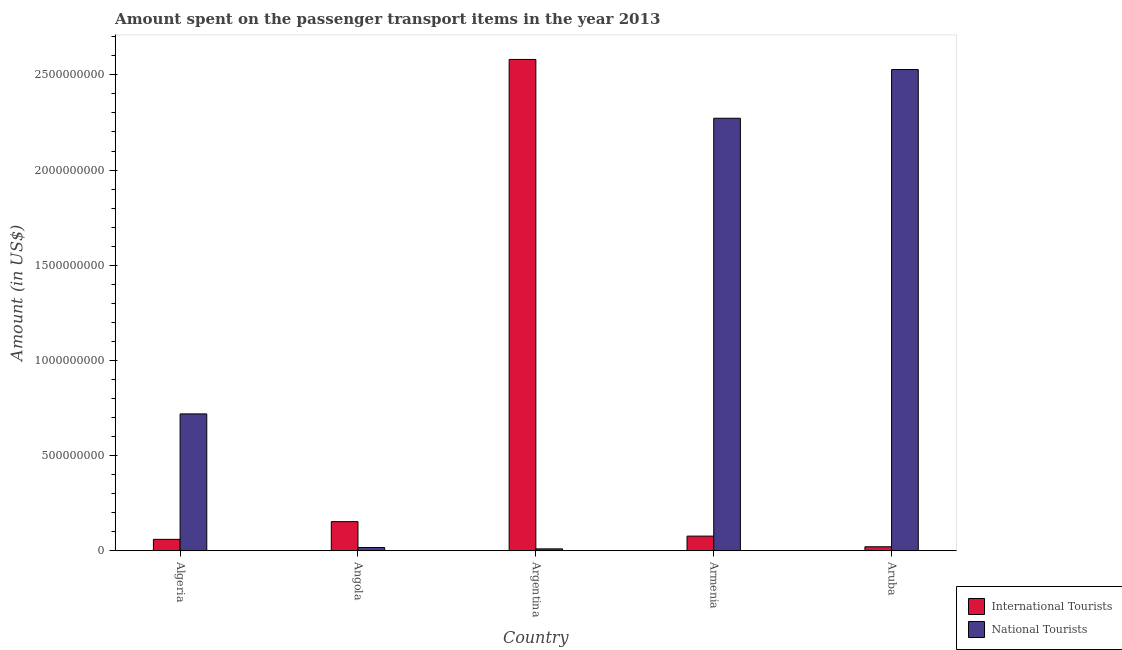How many different coloured bars are there?
Provide a short and direct response. 2. How many groups of bars are there?
Provide a short and direct response. 5. How many bars are there on the 4th tick from the right?
Your response must be concise. 2. What is the label of the 4th group of bars from the left?
Offer a terse response. Armenia. In how many cases, is the number of bars for a given country not equal to the number of legend labels?
Ensure brevity in your answer.  0. Across all countries, what is the maximum amount spent on transport items of international tourists?
Offer a very short reply. 2.58e+09. Across all countries, what is the minimum amount spent on transport items of international tourists?
Offer a terse response. 2.10e+07. In which country was the amount spent on transport items of international tourists maximum?
Provide a succinct answer. Argentina. In which country was the amount spent on transport items of international tourists minimum?
Provide a succinct answer. Aruba. What is the total amount spent on transport items of national tourists in the graph?
Keep it short and to the point. 5.55e+09. What is the difference between the amount spent on transport items of international tourists in Argentina and that in Aruba?
Provide a short and direct response. 2.56e+09. What is the difference between the amount spent on transport items of national tourists in Argentina and the amount spent on transport items of international tourists in Armenia?
Your answer should be very brief. -6.70e+07. What is the average amount spent on transport items of international tourists per country?
Offer a terse response. 5.78e+08. What is the difference between the amount spent on transport items of international tourists and amount spent on transport items of national tourists in Angola?
Offer a very short reply. 1.36e+08. What is the ratio of the amount spent on transport items of national tourists in Argentina to that in Aruba?
Your answer should be compact. 0. Is the difference between the amount spent on transport items of national tourists in Angola and Aruba greater than the difference between the amount spent on transport items of international tourists in Angola and Aruba?
Provide a succinct answer. No. What is the difference between the highest and the second highest amount spent on transport items of international tourists?
Provide a succinct answer. 2.43e+09. What is the difference between the highest and the lowest amount spent on transport items of national tourists?
Provide a short and direct response. 2.52e+09. What does the 2nd bar from the left in Argentina represents?
Keep it short and to the point. National Tourists. What does the 2nd bar from the right in Armenia represents?
Ensure brevity in your answer.  International Tourists. Are all the bars in the graph horizontal?
Ensure brevity in your answer.  No. Are the values on the major ticks of Y-axis written in scientific E-notation?
Offer a very short reply. No. What is the title of the graph?
Your answer should be very brief. Amount spent on the passenger transport items in the year 2013. Does "Female entrants" appear as one of the legend labels in the graph?
Your answer should be compact. No. What is the label or title of the Y-axis?
Offer a very short reply. Amount (in US$). What is the Amount (in US$) in International Tourists in Algeria?
Offer a terse response. 6.00e+07. What is the Amount (in US$) in National Tourists in Algeria?
Your response must be concise. 7.19e+08. What is the Amount (in US$) of International Tourists in Angola?
Your answer should be compact. 1.53e+08. What is the Amount (in US$) of National Tourists in Angola?
Keep it short and to the point. 1.70e+07. What is the Amount (in US$) in International Tourists in Argentina?
Provide a short and direct response. 2.58e+09. What is the Amount (in US$) in International Tourists in Armenia?
Give a very brief answer. 7.70e+07. What is the Amount (in US$) in National Tourists in Armenia?
Your answer should be compact. 2.27e+09. What is the Amount (in US$) in International Tourists in Aruba?
Make the answer very short. 2.10e+07. What is the Amount (in US$) of National Tourists in Aruba?
Your answer should be very brief. 2.53e+09. Across all countries, what is the maximum Amount (in US$) in International Tourists?
Ensure brevity in your answer.  2.58e+09. Across all countries, what is the maximum Amount (in US$) in National Tourists?
Give a very brief answer. 2.53e+09. Across all countries, what is the minimum Amount (in US$) of International Tourists?
Give a very brief answer. 2.10e+07. Across all countries, what is the minimum Amount (in US$) in National Tourists?
Make the answer very short. 1.00e+07. What is the total Amount (in US$) in International Tourists in the graph?
Give a very brief answer. 2.89e+09. What is the total Amount (in US$) in National Tourists in the graph?
Keep it short and to the point. 5.55e+09. What is the difference between the Amount (in US$) of International Tourists in Algeria and that in Angola?
Provide a short and direct response. -9.30e+07. What is the difference between the Amount (in US$) of National Tourists in Algeria and that in Angola?
Your response must be concise. 7.02e+08. What is the difference between the Amount (in US$) in International Tourists in Algeria and that in Argentina?
Your response must be concise. -2.52e+09. What is the difference between the Amount (in US$) in National Tourists in Algeria and that in Argentina?
Keep it short and to the point. 7.09e+08. What is the difference between the Amount (in US$) of International Tourists in Algeria and that in Armenia?
Keep it short and to the point. -1.70e+07. What is the difference between the Amount (in US$) of National Tourists in Algeria and that in Armenia?
Your answer should be compact. -1.55e+09. What is the difference between the Amount (in US$) of International Tourists in Algeria and that in Aruba?
Ensure brevity in your answer.  3.90e+07. What is the difference between the Amount (in US$) of National Tourists in Algeria and that in Aruba?
Provide a short and direct response. -1.81e+09. What is the difference between the Amount (in US$) in International Tourists in Angola and that in Argentina?
Ensure brevity in your answer.  -2.43e+09. What is the difference between the Amount (in US$) in National Tourists in Angola and that in Argentina?
Ensure brevity in your answer.  7.00e+06. What is the difference between the Amount (in US$) of International Tourists in Angola and that in Armenia?
Give a very brief answer. 7.60e+07. What is the difference between the Amount (in US$) of National Tourists in Angola and that in Armenia?
Ensure brevity in your answer.  -2.26e+09. What is the difference between the Amount (in US$) in International Tourists in Angola and that in Aruba?
Your response must be concise. 1.32e+08. What is the difference between the Amount (in US$) in National Tourists in Angola and that in Aruba?
Provide a short and direct response. -2.51e+09. What is the difference between the Amount (in US$) in International Tourists in Argentina and that in Armenia?
Make the answer very short. 2.50e+09. What is the difference between the Amount (in US$) in National Tourists in Argentina and that in Armenia?
Ensure brevity in your answer.  -2.26e+09. What is the difference between the Amount (in US$) of International Tourists in Argentina and that in Aruba?
Give a very brief answer. 2.56e+09. What is the difference between the Amount (in US$) of National Tourists in Argentina and that in Aruba?
Your answer should be compact. -2.52e+09. What is the difference between the Amount (in US$) in International Tourists in Armenia and that in Aruba?
Provide a short and direct response. 5.60e+07. What is the difference between the Amount (in US$) of National Tourists in Armenia and that in Aruba?
Provide a short and direct response. -2.56e+08. What is the difference between the Amount (in US$) in International Tourists in Algeria and the Amount (in US$) in National Tourists in Angola?
Provide a short and direct response. 4.30e+07. What is the difference between the Amount (in US$) in International Tourists in Algeria and the Amount (in US$) in National Tourists in Armenia?
Your answer should be very brief. -2.21e+09. What is the difference between the Amount (in US$) in International Tourists in Algeria and the Amount (in US$) in National Tourists in Aruba?
Keep it short and to the point. -2.47e+09. What is the difference between the Amount (in US$) in International Tourists in Angola and the Amount (in US$) in National Tourists in Argentina?
Offer a terse response. 1.43e+08. What is the difference between the Amount (in US$) of International Tourists in Angola and the Amount (in US$) of National Tourists in Armenia?
Keep it short and to the point. -2.12e+09. What is the difference between the Amount (in US$) in International Tourists in Angola and the Amount (in US$) in National Tourists in Aruba?
Provide a short and direct response. -2.38e+09. What is the difference between the Amount (in US$) in International Tourists in Argentina and the Amount (in US$) in National Tourists in Armenia?
Your response must be concise. 3.09e+08. What is the difference between the Amount (in US$) of International Tourists in Argentina and the Amount (in US$) of National Tourists in Aruba?
Your response must be concise. 5.30e+07. What is the difference between the Amount (in US$) in International Tourists in Armenia and the Amount (in US$) in National Tourists in Aruba?
Provide a short and direct response. -2.45e+09. What is the average Amount (in US$) of International Tourists per country?
Your answer should be very brief. 5.78e+08. What is the average Amount (in US$) in National Tourists per country?
Offer a terse response. 1.11e+09. What is the difference between the Amount (in US$) in International Tourists and Amount (in US$) in National Tourists in Algeria?
Your answer should be compact. -6.59e+08. What is the difference between the Amount (in US$) in International Tourists and Amount (in US$) in National Tourists in Angola?
Your answer should be compact. 1.36e+08. What is the difference between the Amount (in US$) in International Tourists and Amount (in US$) in National Tourists in Argentina?
Provide a succinct answer. 2.57e+09. What is the difference between the Amount (in US$) in International Tourists and Amount (in US$) in National Tourists in Armenia?
Your response must be concise. -2.20e+09. What is the difference between the Amount (in US$) in International Tourists and Amount (in US$) in National Tourists in Aruba?
Keep it short and to the point. -2.51e+09. What is the ratio of the Amount (in US$) of International Tourists in Algeria to that in Angola?
Give a very brief answer. 0.39. What is the ratio of the Amount (in US$) of National Tourists in Algeria to that in Angola?
Your response must be concise. 42.29. What is the ratio of the Amount (in US$) in International Tourists in Algeria to that in Argentina?
Make the answer very short. 0.02. What is the ratio of the Amount (in US$) of National Tourists in Algeria to that in Argentina?
Your answer should be very brief. 71.9. What is the ratio of the Amount (in US$) of International Tourists in Algeria to that in Armenia?
Your answer should be compact. 0.78. What is the ratio of the Amount (in US$) of National Tourists in Algeria to that in Armenia?
Offer a very short reply. 0.32. What is the ratio of the Amount (in US$) in International Tourists in Algeria to that in Aruba?
Make the answer very short. 2.86. What is the ratio of the Amount (in US$) in National Tourists in Algeria to that in Aruba?
Your response must be concise. 0.28. What is the ratio of the Amount (in US$) in International Tourists in Angola to that in Argentina?
Give a very brief answer. 0.06. What is the ratio of the Amount (in US$) in International Tourists in Angola to that in Armenia?
Provide a short and direct response. 1.99. What is the ratio of the Amount (in US$) of National Tourists in Angola to that in Armenia?
Your answer should be compact. 0.01. What is the ratio of the Amount (in US$) in International Tourists in Angola to that in Aruba?
Keep it short and to the point. 7.29. What is the ratio of the Amount (in US$) of National Tourists in Angola to that in Aruba?
Your answer should be very brief. 0.01. What is the ratio of the Amount (in US$) of International Tourists in Argentina to that in Armenia?
Your response must be concise. 33.52. What is the ratio of the Amount (in US$) of National Tourists in Argentina to that in Armenia?
Provide a short and direct response. 0. What is the ratio of the Amount (in US$) in International Tourists in Argentina to that in Aruba?
Keep it short and to the point. 122.9. What is the ratio of the Amount (in US$) in National Tourists in Argentina to that in Aruba?
Provide a short and direct response. 0. What is the ratio of the Amount (in US$) in International Tourists in Armenia to that in Aruba?
Your answer should be very brief. 3.67. What is the ratio of the Amount (in US$) of National Tourists in Armenia to that in Aruba?
Ensure brevity in your answer.  0.9. What is the difference between the highest and the second highest Amount (in US$) of International Tourists?
Offer a very short reply. 2.43e+09. What is the difference between the highest and the second highest Amount (in US$) in National Tourists?
Your response must be concise. 2.56e+08. What is the difference between the highest and the lowest Amount (in US$) in International Tourists?
Offer a very short reply. 2.56e+09. What is the difference between the highest and the lowest Amount (in US$) in National Tourists?
Your answer should be compact. 2.52e+09. 